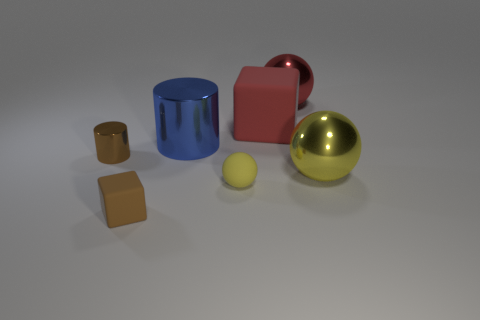Add 3 large matte objects. How many objects exist? 10 Subtract all cylinders. How many objects are left? 5 Subtract all big blue shiny cylinders. Subtract all metal cylinders. How many objects are left? 4 Add 3 balls. How many balls are left? 6 Add 7 tiny brown matte objects. How many tiny brown matte objects exist? 8 Subtract 0 gray cylinders. How many objects are left? 7 